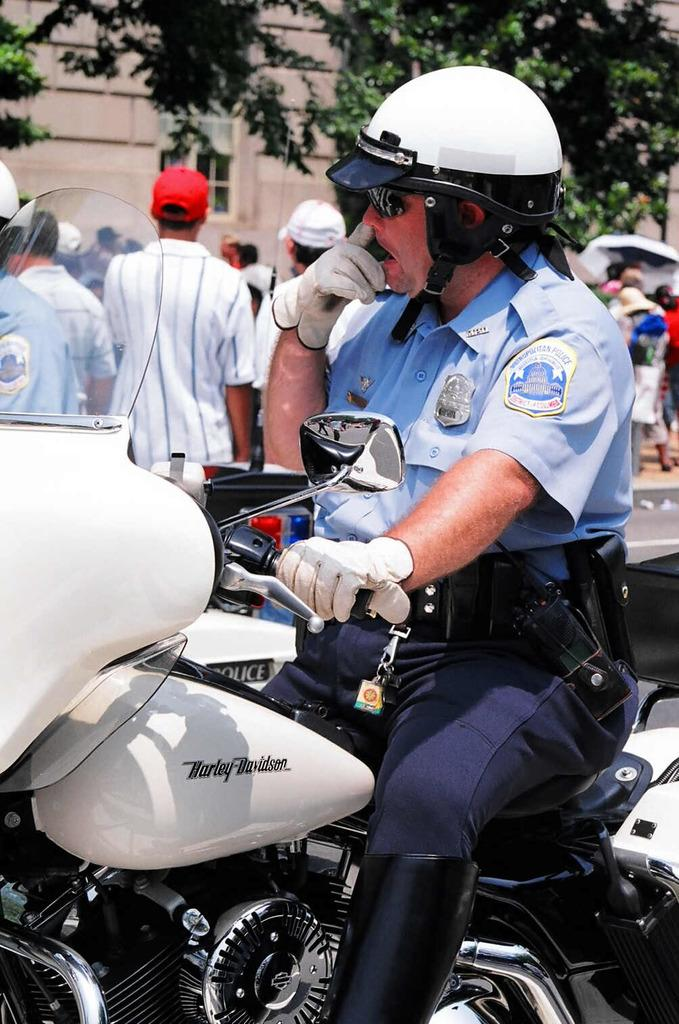What is the main subject of the image? The main subject of the image is a policeman. What is the policeman doing in the image? The policeman is sitting on a motorbike. What protective gear is the policeman wearing? The policeman is wearing a helmet. Can you describe the people behind the policeman? There are people behind the policeman, but their specific actions or appearances are not mentioned in the facts. What can be seen in the background of the image? There is a tree and a building in the background of the image. How many pages does the bubble contain in the image? There is no bubble present in the image, so it is not possible to determine how many pages it might contain. 